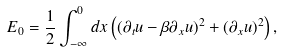Convert formula to latex. <formula><loc_0><loc_0><loc_500><loc_500>E _ { 0 } = \frac { 1 } { 2 } \int _ { - \infty } ^ { 0 } d x \left ( ( \partial _ { t } u - \beta \partial _ { x } u ) ^ { 2 } + ( \partial _ { x } u ) ^ { 2 } \right ) ,</formula> 